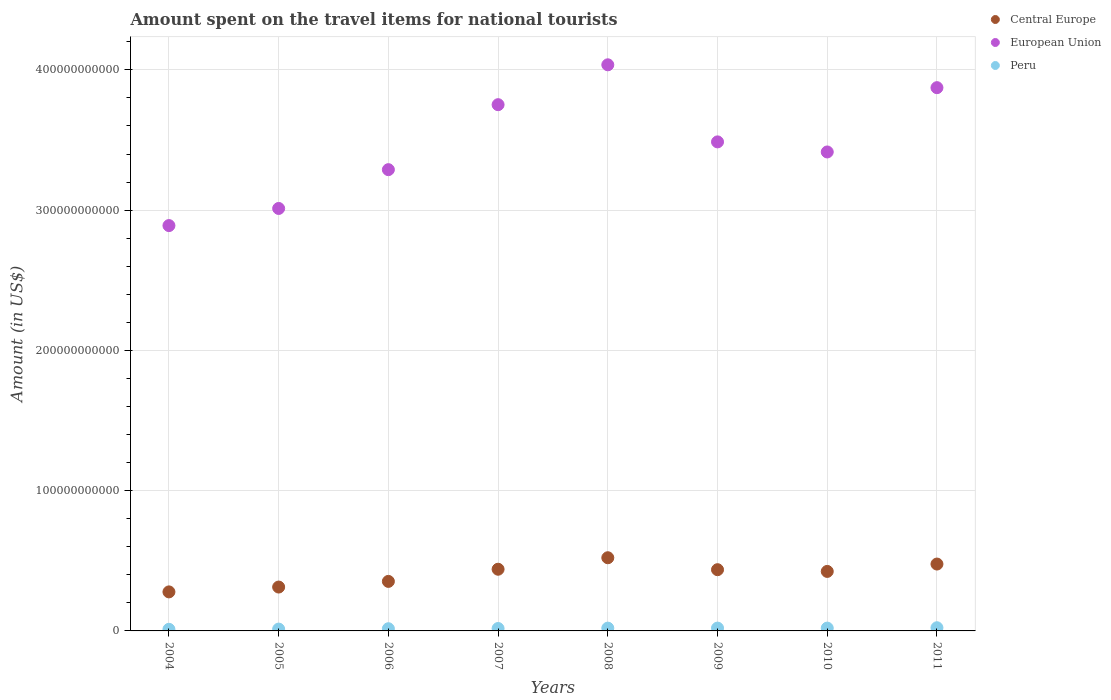How many different coloured dotlines are there?
Your answer should be compact. 3. Is the number of dotlines equal to the number of legend labels?
Provide a short and direct response. Yes. What is the amount spent on the travel items for national tourists in European Union in 2010?
Your answer should be very brief. 3.41e+11. Across all years, what is the maximum amount spent on the travel items for national tourists in Peru?
Your answer should be very brief. 2.26e+09. Across all years, what is the minimum amount spent on the travel items for national tourists in Central Europe?
Offer a very short reply. 2.78e+1. In which year was the amount spent on the travel items for national tourists in European Union maximum?
Your answer should be compact. 2008. What is the total amount spent on the travel items for national tourists in Peru in the graph?
Ensure brevity in your answer.  1.40e+1. What is the difference between the amount spent on the travel items for national tourists in European Union in 2007 and that in 2009?
Your response must be concise. 2.65e+1. What is the difference between the amount spent on the travel items for national tourists in European Union in 2004 and the amount spent on the travel items for national tourists in Peru in 2010?
Keep it short and to the point. 2.87e+11. What is the average amount spent on the travel items for national tourists in European Union per year?
Make the answer very short. 3.47e+11. In the year 2007, what is the difference between the amount spent on the travel items for national tourists in European Union and amount spent on the travel items for national tourists in Peru?
Provide a short and direct response. 3.73e+11. What is the ratio of the amount spent on the travel items for national tourists in Peru in 2005 to that in 2008?
Provide a succinct answer. 0.66. Is the difference between the amount spent on the travel items for national tourists in European Union in 2008 and 2010 greater than the difference between the amount spent on the travel items for national tourists in Peru in 2008 and 2010?
Your answer should be compact. Yes. What is the difference between the highest and the second highest amount spent on the travel items for national tourists in European Union?
Your answer should be compact. 1.63e+1. What is the difference between the highest and the lowest amount spent on the travel items for national tourists in Peru?
Provide a short and direct response. 1.12e+09. Is the sum of the amount spent on the travel items for national tourists in Peru in 2006 and 2009 greater than the maximum amount spent on the travel items for national tourists in European Union across all years?
Your answer should be compact. No. Does the amount spent on the travel items for national tourists in European Union monotonically increase over the years?
Ensure brevity in your answer.  No. Is the amount spent on the travel items for national tourists in Central Europe strictly greater than the amount spent on the travel items for national tourists in Peru over the years?
Your answer should be compact. Yes. How many dotlines are there?
Make the answer very short. 3. What is the difference between two consecutive major ticks on the Y-axis?
Your response must be concise. 1.00e+11. Are the values on the major ticks of Y-axis written in scientific E-notation?
Ensure brevity in your answer.  No. Does the graph contain grids?
Provide a short and direct response. Yes. What is the title of the graph?
Your response must be concise. Amount spent on the travel items for national tourists. What is the label or title of the X-axis?
Provide a short and direct response. Years. What is the Amount (in US$) of Central Europe in 2004?
Give a very brief answer. 2.78e+1. What is the Amount (in US$) in European Union in 2004?
Offer a very short reply. 2.89e+11. What is the Amount (in US$) in Peru in 2004?
Offer a very short reply. 1.14e+09. What is the Amount (in US$) in Central Europe in 2005?
Your response must be concise. 3.13e+1. What is the Amount (in US$) in European Union in 2005?
Ensure brevity in your answer.  3.01e+11. What is the Amount (in US$) of Peru in 2005?
Ensure brevity in your answer.  1.31e+09. What is the Amount (in US$) in Central Europe in 2006?
Make the answer very short. 3.53e+1. What is the Amount (in US$) of European Union in 2006?
Provide a short and direct response. 3.29e+11. What is the Amount (in US$) of Peru in 2006?
Provide a short and direct response. 1.57e+09. What is the Amount (in US$) of Central Europe in 2007?
Make the answer very short. 4.40e+1. What is the Amount (in US$) in European Union in 2007?
Your response must be concise. 3.75e+11. What is the Amount (in US$) in Peru in 2007?
Ensure brevity in your answer.  1.72e+09. What is the Amount (in US$) in Central Europe in 2008?
Provide a succinct answer. 5.22e+1. What is the Amount (in US$) in European Union in 2008?
Your answer should be very brief. 4.04e+11. What is the Amount (in US$) of Peru in 2008?
Offer a very short reply. 1.99e+09. What is the Amount (in US$) of Central Europe in 2009?
Keep it short and to the point. 4.37e+1. What is the Amount (in US$) in European Union in 2009?
Your answer should be very brief. 3.49e+11. What is the Amount (in US$) of Peru in 2009?
Your answer should be compact. 2.01e+09. What is the Amount (in US$) of Central Europe in 2010?
Ensure brevity in your answer.  4.24e+1. What is the Amount (in US$) in European Union in 2010?
Provide a short and direct response. 3.41e+11. What is the Amount (in US$) in Peru in 2010?
Give a very brief answer. 2.01e+09. What is the Amount (in US$) in Central Europe in 2011?
Your answer should be very brief. 4.77e+1. What is the Amount (in US$) of European Union in 2011?
Offer a terse response. 3.87e+11. What is the Amount (in US$) in Peru in 2011?
Make the answer very short. 2.26e+09. Across all years, what is the maximum Amount (in US$) in Central Europe?
Provide a short and direct response. 5.22e+1. Across all years, what is the maximum Amount (in US$) of European Union?
Offer a terse response. 4.04e+11. Across all years, what is the maximum Amount (in US$) in Peru?
Keep it short and to the point. 2.26e+09. Across all years, what is the minimum Amount (in US$) in Central Europe?
Ensure brevity in your answer.  2.78e+1. Across all years, what is the minimum Amount (in US$) in European Union?
Make the answer very short. 2.89e+11. Across all years, what is the minimum Amount (in US$) in Peru?
Ensure brevity in your answer.  1.14e+09. What is the total Amount (in US$) of Central Europe in the graph?
Make the answer very short. 3.24e+11. What is the total Amount (in US$) of European Union in the graph?
Give a very brief answer. 2.78e+12. What is the total Amount (in US$) in Peru in the graph?
Offer a very short reply. 1.40e+1. What is the difference between the Amount (in US$) in Central Europe in 2004 and that in 2005?
Your answer should be compact. -3.45e+09. What is the difference between the Amount (in US$) in European Union in 2004 and that in 2005?
Your answer should be very brief. -1.22e+1. What is the difference between the Amount (in US$) in Peru in 2004 and that in 2005?
Your answer should be very brief. -1.66e+08. What is the difference between the Amount (in US$) of Central Europe in 2004 and that in 2006?
Offer a very short reply. -7.48e+09. What is the difference between the Amount (in US$) of European Union in 2004 and that in 2006?
Offer a terse response. -3.99e+1. What is the difference between the Amount (in US$) in Peru in 2004 and that in 2006?
Offer a terse response. -4.28e+08. What is the difference between the Amount (in US$) of Central Europe in 2004 and that in 2007?
Offer a terse response. -1.62e+1. What is the difference between the Amount (in US$) in European Union in 2004 and that in 2007?
Offer a terse response. -8.62e+1. What is the difference between the Amount (in US$) in Peru in 2004 and that in 2007?
Keep it short and to the point. -5.81e+08. What is the difference between the Amount (in US$) in Central Europe in 2004 and that in 2008?
Give a very brief answer. -2.44e+1. What is the difference between the Amount (in US$) in European Union in 2004 and that in 2008?
Your response must be concise. -1.15e+11. What is the difference between the Amount (in US$) of Peru in 2004 and that in 2008?
Offer a very short reply. -8.49e+08. What is the difference between the Amount (in US$) of Central Europe in 2004 and that in 2009?
Ensure brevity in your answer.  -1.58e+1. What is the difference between the Amount (in US$) of European Union in 2004 and that in 2009?
Keep it short and to the point. -5.97e+1. What is the difference between the Amount (in US$) of Peru in 2004 and that in 2009?
Your response must be concise. -8.72e+08. What is the difference between the Amount (in US$) of Central Europe in 2004 and that in 2010?
Provide a succinct answer. -1.46e+1. What is the difference between the Amount (in US$) in European Union in 2004 and that in 2010?
Your answer should be compact. -5.25e+1. What is the difference between the Amount (in US$) of Peru in 2004 and that in 2010?
Make the answer very short. -8.66e+08. What is the difference between the Amount (in US$) in Central Europe in 2004 and that in 2011?
Give a very brief answer. -1.99e+1. What is the difference between the Amount (in US$) of European Union in 2004 and that in 2011?
Provide a succinct answer. -9.83e+1. What is the difference between the Amount (in US$) in Peru in 2004 and that in 2011?
Offer a terse response. -1.12e+09. What is the difference between the Amount (in US$) of Central Europe in 2005 and that in 2006?
Make the answer very short. -4.03e+09. What is the difference between the Amount (in US$) in European Union in 2005 and that in 2006?
Offer a very short reply. -2.77e+1. What is the difference between the Amount (in US$) of Peru in 2005 and that in 2006?
Give a very brief answer. -2.62e+08. What is the difference between the Amount (in US$) of Central Europe in 2005 and that in 2007?
Provide a short and direct response. -1.27e+1. What is the difference between the Amount (in US$) of European Union in 2005 and that in 2007?
Ensure brevity in your answer.  -7.40e+1. What is the difference between the Amount (in US$) of Peru in 2005 and that in 2007?
Give a very brief answer. -4.15e+08. What is the difference between the Amount (in US$) in Central Europe in 2005 and that in 2008?
Make the answer very short. -2.09e+1. What is the difference between the Amount (in US$) of European Union in 2005 and that in 2008?
Your response must be concise. -1.02e+11. What is the difference between the Amount (in US$) of Peru in 2005 and that in 2008?
Ensure brevity in your answer.  -6.83e+08. What is the difference between the Amount (in US$) in Central Europe in 2005 and that in 2009?
Offer a terse response. -1.24e+1. What is the difference between the Amount (in US$) of European Union in 2005 and that in 2009?
Give a very brief answer. -4.75e+1. What is the difference between the Amount (in US$) in Peru in 2005 and that in 2009?
Ensure brevity in your answer.  -7.06e+08. What is the difference between the Amount (in US$) in Central Europe in 2005 and that in 2010?
Make the answer very short. -1.11e+1. What is the difference between the Amount (in US$) of European Union in 2005 and that in 2010?
Your answer should be very brief. -4.03e+1. What is the difference between the Amount (in US$) of Peru in 2005 and that in 2010?
Your answer should be compact. -7.00e+08. What is the difference between the Amount (in US$) in Central Europe in 2005 and that in 2011?
Offer a terse response. -1.64e+1. What is the difference between the Amount (in US$) of European Union in 2005 and that in 2011?
Your answer should be very brief. -8.61e+1. What is the difference between the Amount (in US$) of Peru in 2005 and that in 2011?
Ensure brevity in your answer.  -9.54e+08. What is the difference between the Amount (in US$) in Central Europe in 2006 and that in 2007?
Make the answer very short. -8.67e+09. What is the difference between the Amount (in US$) in European Union in 2006 and that in 2007?
Offer a very short reply. -4.63e+1. What is the difference between the Amount (in US$) of Peru in 2006 and that in 2007?
Make the answer very short. -1.53e+08. What is the difference between the Amount (in US$) of Central Europe in 2006 and that in 2008?
Provide a succinct answer. -1.69e+1. What is the difference between the Amount (in US$) in European Union in 2006 and that in 2008?
Give a very brief answer. -7.48e+1. What is the difference between the Amount (in US$) of Peru in 2006 and that in 2008?
Provide a succinct answer. -4.21e+08. What is the difference between the Amount (in US$) in Central Europe in 2006 and that in 2009?
Your response must be concise. -8.34e+09. What is the difference between the Amount (in US$) in European Union in 2006 and that in 2009?
Offer a terse response. -1.98e+1. What is the difference between the Amount (in US$) of Peru in 2006 and that in 2009?
Provide a succinct answer. -4.44e+08. What is the difference between the Amount (in US$) in Central Europe in 2006 and that in 2010?
Provide a short and direct response. -7.11e+09. What is the difference between the Amount (in US$) of European Union in 2006 and that in 2010?
Your answer should be compact. -1.26e+1. What is the difference between the Amount (in US$) in Peru in 2006 and that in 2010?
Keep it short and to the point. -4.38e+08. What is the difference between the Amount (in US$) of Central Europe in 2006 and that in 2011?
Make the answer very short. -1.24e+1. What is the difference between the Amount (in US$) in European Union in 2006 and that in 2011?
Make the answer very short. -5.85e+1. What is the difference between the Amount (in US$) of Peru in 2006 and that in 2011?
Provide a short and direct response. -6.92e+08. What is the difference between the Amount (in US$) of Central Europe in 2007 and that in 2008?
Keep it short and to the point. -8.20e+09. What is the difference between the Amount (in US$) of European Union in 2007 and that in 2008?
Make the answer very short. -2.84e+1. What is the difference between the Amount (in US$) in Peru in 2007 and that in 2008?
Offer a very short reply. -2.68e+08. What is the difference between the Amount (in US$) in Central Europe in 2007 and that in 2009?
Your answer should be very brief. 3.28e+08. What is the difference between the Amount (in US$) of European Union in 2007 and that in 2009?
Offer a terse response. 2.65e+1. What is the difference between the Amount (in US$) in Peru in 2007 and that in 2009?
Offer a very short reply. -2.91e+08. What is the difference between the Amount (in US$) of Central Europe in 2007 and that in 2010?
Your answer should be very brief. 1.56e+09. What is the difference between the Amount (in US$) of European Union in 2007 and that in 2010?
Offer a terse response. 3.37e+1. What is the difference between the Amount (in US$) of Peru in 2007 and that in 2010?
Give a very brief answer. -2.85e+08. What is the difference between the Amount (in US$) of Central Europe in 2007 and that in 2011?
Your answer should be very brief. -3.70e+09. What is the difference between the Amount (in US$) of European Union in 2007 and that in 2011?
Make the answer very short. -1.21e+1. What is the difference between the Amount (in US$) in Peru in 2007 and that in 2011?
Your response must be concise. -5.39e+08. What is the difference between the Amount (in US$) in Central Europe in 2008 and that in 2009?
Your answer should be compact. 8.52e+09. What is the difference between the Amount (in US$) of European Union in 2008 and that in 2009?
Offer a very short reply. 5.50e+1. What is the difference between the Amount (in US$) of Peru in 2008 and that in 2009?
Provide a succinct answer. -2.30e+07. What is the difference between the Amount (in US$) of Central Europe in 2008 and that in 2010?
Give a very brief answer. 9.75e+09. What is the difference between the Amount (in US$) in European Union in 2008 and that in 2010?
Keep it short and to the point. 6.21e+1. What is the difference between the Amount (in US$) of Peru in 2008 and that in 2010?
Make the answer very short. -1.70e+07. What is the difference between the Amount (in US$) in Central Europe in 2008 and that in 2011?
Your response must be concise. 4.50e+09. What is the difference between the Amount (in US$) of European Union in 2008 and that in 2011?
Ensure brevity in your answer.  1.63e+1. What is the difference between the Amount (in US$) of Peru in 2008 and that in 2011?
Your answer should be compact. -2.71e+08. What is the difference between the Amount (in US$) in Central Europe in 2009 and that in 2010?
Your answer should be very brief. 1.23e+09. What is the difference between the Amount (in US$) in European Union in 2009 and that in 2010?
Your response must be concise. 7.18e+09. What is the difference between the Amount (in US$) in Peru in 2009 and that in 2010?
Provide a short and direct response. 6.00e+06. What is the difference between the Amount (in US$) in Central Europe in 2009 and that in 2011?
Provide a succinct answer. -4.02e+09. What is the difference between the Amount (in US$) in European Union in 2009 and that in 2011?
Provide a short and direct response. -3.87e+1. What is the difference between the Amount (in US$) of Peru in 2009 and that in 2011?
Give a very brief answer. -2.48e+08. What is the difference between the Amount (in US$) in Central Europe in 2010 and that in 2011?
Give a very brief answer. -5.25e+09. What is the difference between the Amount (in US$) of European Union in 2010 and that in 2011?
Your answer should be compact. -4.58e+1. What is the difference between the Amount (in US$) in Peru in 2010 and that in 2011?
Provide a succinct answer. -2.54e+08. What is the difference between the Amount (in US$) of Central Europe in 2004 and the Amount (in US$) of European Union in 2005?
Ensure brevity in your answer.  -2.73e+11. What is the difference between the Amount (in US$) of Central Europe in 2004 and the Amount (in US$) of Peru in 2005?
Your answer should be very brief. 2.65e+1. What is the difference between the Amount (in US$) of European Union in 2004 and the Amount (in US$) of Peru in 2005?
Provide a succinct answer. 2.88e+11. What is the difference between the Amount (in US$) of Central Europe in 2004 and the Amount (in US$) of European Union in 2006?
Your answer should be compact. -3.01e+11. What is the difference between the Amount (in US$) of Central Europe in 2004 and the Amount (in US$) of Peru in 2006?
Offer a terse response. 2.63e+1. What is the difference between the Amount (in US$) in European Union in 2004 and the Amount (in US$) in Peru in 2006?
Ensure brevity in your answer.  2.87e+11. What is the difference between the Amount (in US$) of Central Europe in 2004 and the Amount (in US$) of European Union in 2007?
Make the answer very short. -3.47e+11. What is the difference between the Amount (in US$) of Central Europe in 2004 and the Amount (in US$) of Peru in 2007?
Offer a terse response. 2.61e+1. What is the difference between the Amount (in US$) of European Union in 2004 and the Amount (in US$) of Peru in 2007?
Offer a terse response. 2.87e+11. What is the difference between the Amount (in US$) of Central Europe in 2004 and the Amount (in US$) of European Union in 2008?
Make the answer very short. -3.76e+11. What is the difference between the Amount (in US$) of Central Europe in 2004 and the Amount (in US$) of Peru in 2008?
Make the answer very short. 2.58e+1. What is the difference between the Amount (in US$) of European Union in 2004 and the Amount (in US$) of Peru in 2008?
Provide a succinct answer. 2.87e+11. What is the difference between the Amount (in US$) of Central Europe in 2004 and the Amount (in US$) of European Union in 2009?
Your answer should be compact. -3.21e+11. What is the difference between the Amount (in US$) in Central Europe in 2004 and the Amount (in US$) in Peru in 2009?
Your response must be concise. 2.58e+1. What is the difference between the Amount (in US$) in European Union in 2004 and the Amount (in US$) in Peru in 2009?
Your answer should be compact. 2.87e+11. What is the difference between the Amount (in US$) in Central Europe in 2004 and the Amount (in US$) in European Union in 2010?
Your response must be concise. -3.14e+11. What is the difference between the Amount (in US$) in Central Europe in 2004 and the Amount (in US$) in Peru in 2010?
Provide a short and direct response. 2.58e+1. What is the difference between the Amount (in US$) of European Union in 2004 and the Amount (in US$) of Peru in 2010?
Keep it short and to the point. 2.87e+11. What is the difference between the Amount (in US$) of Central Europe in 2004 and the Amount (in US$) of European Union in 2011?
Ensure brevity in your answer.  -3.59e+11. What is the difference between the Amount (in US$) in Central Europe in 2004 and the Amount (in US$) in Peru in 2011?
Your response must be concise. 2.56e+1. What is the difference between the Amount (in US$) of European Union in 2004 and the Amount (in US$) of Peru in 2011?
Ensure brevity in your answer.  2.87e+11. What is the difference between the Amount (in US$) of Central Europe in 2005 and the Amount (in US$) of European Union in 2006?
Offer a very short reply. -2.98e+11. What is the difference between the Amount (in US$) of Central Europe in 2005 and the Amount (in US$) of Peru in 2006?
Provide a succinct answer. 2.97e+1. What is the difference between the Amount (in US$) of European Union in 2005 and the Amount (in US$) of Peru in 2006?
Offer a terse response. 3.00e+11. What is the difference between the Amount (in US$) of Central Europe in 2005 and the Amount (in US$) of European Union in 2007?
Your answer should be very brief. -3.44e+11. What is the difference between the Amount (in US$) of Central Europe in 2005 and the Amount (in US$) of Peru in 2007?
Your answer should be very brief. 2.96e+1. What is the difference between the Amount (in US$) of European Union in 2005 and the Amount (in US$) of Peru in 2007?
Make the answer very short. 2.99e+11. What is the difference between the Amount (in US$) of Central Europe in 2005 and the Amount (in US$) of European Union in 2008?
Provide a short and direct response. -3.72e+11. What is the difference between the Amount (in US$) of Central Europe in 2005 and the Amount (in US$) of Peru in 2008?
Make the answer very short. 2.93e+1. What is the difference between the Amount (in US$) of European Union in 2005 and the Amount (in US$) of Peru in 2008?
Offer a terse response. 2.99e+11. What is the difference between the Amount (in US$) of Central Europe in 2005 and the Amount (in US$) of European Union in 2009?
Your answer should be very brief. -3.17e+11. What is the difference between the Amount (in US$) of Central Europe in 2005 and the Amount (in US$) of Peru in 2009?
Your response must be concise. 2.93e+1. What is the difference between the Amount (in US$) of European Union in 2005 and the Amount (in US$) of Peru in 2009?
Keep it short and to the point. 2.99e+11. What is the difference between the Amount (in US$) in Central Europe in 2005 and the Amount (in US$) in European Union in 2010?
Offer a very short reply. -3.10e+11. What is the difference between the Amount (in US$) of Central Europe in 2005 and the Amount (in US$) of Peru in 2010?
Offer a terse response. 2.93e+1. What is the difference between the Amount (in US$) in European Union in 2005 and the Amount (in US$) in Peru in 2010?
Make the answer very short. 2.99e+11. What is the difference between the Amount (in US$) in Central Europe in 2005 and the Amount (in US$) in European Union in 2011?
Your answer should be very brief. -3.56e+11. What is the difference between the Amount (in US$) in Central Europe in 2005 and the Amount (in US$) in Peru in 2011?
Offer a terse response. 2.90e+1. What is the difference between the Amount (in US$) of European Union in 2005 and the Amount (in US$) of Peru in 2011?
Your answer should be very brief. 2.99e+11. What is the difference between the Amount (in US$) of Central Europe in 2006 and the Amount (in US$) of European Union in 2007?
Ensure brevity in your answer.  -3.40e+11. What is the difference between the Amount (in US$) of Central Europe in 2006 and the Amount (in US$) of Peru in 2007?
Your answer should be very brief. 3.36e+1. What is the difference between the Amount (in US$) in European Union in 2006 and the Amount (in US$) in Peru in 2007?
Provide a short and direct response. 3.27e+11. What is the difference between the Amount (in US$) in Central Europe in 2006 and the Amount (in US$) in European Union in 2008?
Give a very brief answer. -3.68e+11. What is the difference between the Amount (in US$) in Central Europe in 2006 and the Amount (in US$) in Peru in 2008?
Your answer should be very brief. 3.33e+1. What is the difference between the Amount (in US$) in European Union in 2006 and the Amount (in US$) in Peru in 2008?
Ensure brevity in your answer.  3.27e+11. What is the difference between the Amount (in US$) of Central Europe in 2006 and the Amount (in US$) of European Union in 2009?
Your answer should be compact. -3.13e+11. What is the difference between the Amount (in US$) of Central Europe in 2006 and the Amount (in US$) of Peru in 2009?
Offer a terse response. 3.33e+1. What is the difference between the Amount (in US$) in European Union in 2006 and the Amount (in US$) in Peru in 2009?
Give a very brief answer. 3.27e+11. What is the difference between the Amount (in US$) of Central Europe in 2006 and the Amount (in US$) of European Union in 2010?
Provide a short and direct response. -3.06e+11. What is the difference between the Amount (in US$) in Central Europe in 2006 and the Amount (in US$) in Peru in 2010?
Provide a short and direct response. 3.33e+1. What is the difference between the Amount (in US$) in European Union in 2006 and the Amount (in US$) in Peru in 2010?
Make the answer very short. 3.27e+11. What is the difference between the Amount (in US$) in Central Europe in 2006 and the Amount (in US$) in European Union in 2011?
Ensure brevity in your answer.  -3.52e+11. What is the difference between the Amount (in US$) of Central Europe in 2006 and the Amount (in US$) of Peru in 2011?
Make the answer very short. 3.30e+1. What is the difference between the Amount (in US$) in European Union in 2006 and the Amount (in US$) in Peru in 2011?
Offer a terse response. 3.27e+11. What is the difference between the Amount (in US$) in Central Europe in 2007 and the Amount (in US$) in European Union in 2008?
Make the answer very short. -3.60e+11. What is the difference between the Amount (in US$) in Central Europe in 2007 and the Amount (in US$) in Peru in 2008?
Give a very brief answer. 4.20e+1. What is the difference between the Amount (in US$) of European Union in 2007 and the Amount (in US$) of Peru in 2008?
Offer a terse response. 3.73e+11. What is the difference between the Amount (in US$) of Central Europe in 2007 and the Amount (in US$) of European Union in 2009?
Provide a succinct answer. -3.05e+11. What is the difference between the Amount (in US$) in Central Europe in 2007 and the Amount (in US$) in Peru in 2009?
Offer a very short reply. 4.20e+1. What is the difference between the Amount (in US$) in European Union in 2007 and the Amount (in US$) in Peru in 2009?
Make the answer very short. 3.73e+11. What is the difference between the Amount (in US$) of Central Europe in 2007 and the Amount (in US$) of European Union in 2010?
Your response must be concise. -2.97e+11. What is the difference between the Amount (in US$) of Central Europe in 2007 and the Amount (in US$) of Peru in 2010?
Offer a very short reply. 4.20e+1. What is the difference between the Amount (in US$) of European Union in 2007 and the Amount (in US$) of Peru in 2010?
Offer a very short reply. 3.73e+11. What is the difference between the Amount (in US$) in Central Europe in 2007 and the Amount (in US$) in European Union in 2011?
Offer a terse response. -3.43e+11. What is the difference between the Amount (in US$) in Central Europe in 2007 and the Amount (in US$) in Peru in 2011?
Offer a terse response. 4.17e+1. What is the difference between the Amount (in US$) of European Union in 2007 and the Amount (in US$) of Peru in 2011?
Provide a short and direct response. 3.73e+11. What is the difference between the Amount (in US$) of Central Europe in 2008 and the Amount (in US$) of European Union in 2009?
Your answer should be compact. -2.96e+11. What is the difference between the Amount (in US$) of Central Europe in 2008 and the Amount (in US$) of Peru in 2009?
Keep it short and to the point. 5.02e+1. What is the difference between the Amount (in US$) in European Union in 2008 and the Amount (in US$) in Peru in 2009?
Give a very brief answer. 4.02e+11. What is the difference between the Amount (in US$) in Central Europe in 2008 and the Amount (in US$) in European Union in 2010?
Make the answer very short. -2.89e+11. What is the difference between the Amount (in US$) of Central Europe in 2008 and the Amount (in US$) of Peru in 2010?
Your answer should be very brief. 5.02e+1. What is the difference between the Amount (in US$) in European Union in 2008 and the Amount (in US$) in Peru in 2010?
Provide a succinct answer. 4.02e+11. What is the difference between the Amount (in US$) of Central Europe in 2008 and the Amount (in US$) of European Union in 2011?
Your answer should be very brief. -3.35e+11. What is the difference between the Amount (in US$) of Central Europe in 2008 and the Amount (in US$) of Peru in 2011?
Make the answer very short. 4.99e+1. What is the difference between the Amount (in US$) in European Union in 2008 and the Amount (in US$) in Peru in 2011?
Provide a succinct answer. 4.01e+11. What is the difference between the Amount (in US$) in Central Europe in 2009 and the Amount (in US$) in European Union in 2010?
Your response must be concise. -2.98e+11. What is the difference between the Amount (in US$) in Central Europe in 2009 and the Amount (in US$) in Peru in 2010?
Your answer should be compact. 4.16e+1. What is the difference between the Amount (in US$) of European Union in 2009 and the Amount (in US$) of Peru in 2010?
Your response must be concise. 3.47e+11. What is the difference between the Amount (in US$) in Central Europe in 2009 and the Amount (in US$) in European Union in 2011?
Provide a succinct answer. -3.44e+11. What is the difference between the Amount (in US$) of Central Europe in 2009 and the Amount (in US$) of Peru in 2011?
Give a very brief answer. 4.14e+1. What is the difference between the Amount (in US$) in European Union in 2009 and the Amount (in US$) in Peru in 2011?
Your response must be concise. 3.46e+11. What is the difference between the Amount (in US$) of Central Europe in 2010 and the Amount (in US$) of European Union in 2011?
Give a very brief answer. -3.45e+11. What is the difference between the Amount (in US$) in Central Europe in 2010 and the Amount (in US$) in Peru in 2011?
Keep it short and to the point. 4.02e+1. What is the difference between the Amount (in US$) of European Union in 2010 and the Amount (in US$) of Peru in 2011?
Make the answer very short. 3.39e+11. What is the average Amount (in US$) of Central Europe per year?
Provide a short and direct response. 4.05e+1. What is the average Amount (in US$) in European Union per year?
Provide a succinct answer. 3.47e+11. What is the average Amount (in US$) of Peru per year?
Your answer should be very brief. 1.75e+09. In the year 2004, what is the difference between the Amount (in US$) of Central Europe and Amount (in US$) of European Union?
Make the answer very short. -2.61e+11. In the year 2004, what is the difference between the Amount (in US$) of Central Europe and Amount (in US$) of Peru?
Your response must be concise. 2.67e+1. In the year 2004, what is the difference between the Amount (in US$) of European Union and Amount (in US$) of Peru?
Offer a terse response. 2.88e+11. In the year 2005, what is the difference between the Amount (in US$) in Central Europe and Amount (in US$) in European Union?
Your answer should be very brief. -2.70e+11. In the year 2005, what is the difference between the Amount (in US$) of Central Europe and Amount (in US$) of Peru?
Your answer should be very brief. 3.00e+1. In the year 2005, what is the difference between the Amount (in US$) in European Union and Amount (in US$) in Peru?
Offer a terse response. 3.00e+11. In the year 2006, what is the difference between the Amount (in US$) in Central Europe and Amount (in US$) in European Union?
Give a very brief answer. -2.94e+11. In the year 2006, what is the difference between the Amount (in US$) in Central Europe and Amount (in US$) in Peru?
Ensure brevity in your answer.  3.37e+1. In the year 2006, what is the difference between the Amount (in US$) in European Union and Amount (in US$) in Peru?
Your response must be concise. 3.27e+11. In the year 2007, what is the difference between the Amount (in US$) in Central Europe and Amount (in US$) in European Union?
Provide a succinct answer. -3.31e+11. In the year 2007, what is the difference between the Amount (in US$) of Central Europe and Amount (in US$) of Peru?
Your response must be concise. 4.23e+1. In the year 2007, what is the difference between the Amount (in US$) in European Union and Amount (in US$) in Peru?
Your response must be concise. 3.73e+11. In the year 2008, what is the difference between the Amount (in US$) in Central Europe and Amount (in US$) in European Union?
Make the answer very short. -3.51e+11. In the year 2008, what is the difference between the Amount (in US$) of Central Europe and Amount (in US$) of Peru?
Provide a succinct answer. 5.02e+1. In the year 2008, what is the difference between the Amount (in US$) in European Union and Amount (in US$) in Peru?
Provide a succinct answer. 4.02e+11. In the year 2009, what is the difference between the Amount (in US$) of Central Europe and Amount (in US$) of European Union?
Keep it short and to the point. -3.05e+11. In the year 2009, what is the difference between the Amount (in US$) in Central Europe and Amount (in US$) in Peru?
Provide a short and direct response. 4.16e+1. In the year 2009, what is the difference between the Amount (in US$) in European Union and Amount (in US$) in Peru?
Make the answer very short. 3.47e+11. In the year 2010, what is the difference between the Amount (in US$) in Central Europe and Amount (in US$) in European Union?
Make the answer very short. -2.99e+11. In the year 2010, what is the difference between the Amount (in US$) of Central Europe and Amount (in US$) of Peru?
Your response must be concise. 4.04e+1. In the year 2010, what is the difference between the Amount (in US$) in European Union and Amount (in US$) in Peru?
Provide a short and direct response. 3.39e+11. In the year 2011, what is the difference between the Amount (in US$) of Central Europe and Amount (in US$) of European Union?
Ensure brevity in your answer.  -3.40e+11. In the year 2011, what is the difference between the Amount (in US$) of Central Europe and Amount (in US$) of Peru?
Give a very brief answer. 4.54e+1. In the year 2011, what is the difference between the Amount (in US$) in European Union and Amount (in US$) in Peru?
Offer a very short reply. 3.85e+11. What is the ratio of the Amount (in US$) in Central Europe in 2004 to that in 2005?
Make the answer very short. 0.89. What is the ratio of the Amount (in US$) of European Union in 2004 to that in 2005?
Keep it short and to the point. 0.96. What is the ratio of the Amount (in US$) of Peru in 2004 to that in 2005?
Keep it short and to the point. 0.87. What is the ratio of the Amount (in US$) of Central Europe in 2004 to that in 2006?
Your answer should be compact. 0.79. What is the ratio of the Amount (in US$) of European Union in 2004 to that in 2006?
Give a very brief answer. 0.88. What is the ratio of the Amount (in US$) in Peru in 2004 to that in 2006?
Offer a very short reply. 0.73. What is the ratio of the Amount (in US$) of Central Europe in 2004 to that in 2007?
Make the answer very short. 0.63. What is the ratio of the Amount (in US$) in European Union in 2004 to that in 2007?
Keep it short and to the point. 0.77. What is the ratio of the Amount (in US$) of Peru in 2004 to that in 2007?
Provide a short and direct response. 0.66. What is the ratio of the Amount (in US$) in Central Europe in 2004 to that in 2008?
Make the answer very short. 0.53. What is the ratio of the Amount (in US$) of European Union in 2004 to that in 2008?
Give a very brief answer. 0.72. What is the ratio of the Amount (in US$) of Peru in 2004 to that in 2008?
Ensure brevity in your answer.  0.57. What is the ratio of the Amount (in US$) of Central Europe in 2004 to that in 2009?
Your response must be concise. 0.64. What is the ratio of the Amount (in US$) of European Union in 2004 to that in 2009?
Your answer should be very brief. 0.83. What is the ratio of the Amount (in US$) in Peru in 2004 to that in 2009?
Offer a very short reply. 0.57. What is the ratio of the Amount (in US$) in Central Europe in 2004 to that in 2010?
Give a very brief answer. 0.66. What is the ratio of the Amount (in US$) of European Union in 2004 to that in 2010?
Your answer should be compact. 0.85. What is the ratio of the Amount (in US$) of Peru in 2004 to that in 2010?
Offer a terse response. 0.57. What is the ratio of the Amount (in US$) in Central Europe in 2004 to that in 2011?
Provide a succinct answer. 0.58. What is the ratio of the Amount (in US$) of European Union in 2004 to that in 2011?
Keep it short and to the point. 0.75. What is the ratio of the Amount (in US$) of Peru in 2004 to that in 2011?
Make the answer very short. 0.5. What is the ratio of the Amount (in US$) of Central Europe in 2005 to that in 2006?
Your answer should be very brief. 0.89. What is the ratio of the Amount (in US$) of European Union in 2005 to that in 2006?
Your response must be concise. 0.92. What is the ratio of the Amount (in US$) of Peru in 2005 to that in 2006?
Give a very brief answer. 0.83. What is the ratio of the Amount (in US$) of Central Europe in 2005 to that in 2007?
Your response must be concise. 0.71. What is the ratio of the Amount (in US$) in European Union in 2005 to that in 2007?
Provide a short and direct response. 0.8. What is the ratio of the Amount (in US$) in Peru in 2005 to that in 2007?
Provide a succinct answer. 0.76. What is the ratio of the Amount (in US$) in Central Europe in 2005 to that in 2008?
Your response must be concise. 0.6. What is the ratio of the Amount (in US$) in European Union in 2005 to that in 2008?
Your answer should be compact. 0.75. What is the ratio of the Amount (in US$) of Peru in 2005 to that in 2008?
Keep it short and to the point. 0.66. What is the ratio of the Amount (in US$) in Central Europe in 2005 to that in 2009?
Provide a short and direct response. 0.72. What is the ratio of the Amount (in US$) of European Union in 2005 to that in 2009?
Keep it short and to the point. 0.86. What is the ratio of the Amount (in US$) of Peru in 2005 to that in 2009?
Your response must be concise. 0.65. What is the ratio of the Amount (in US$) in Central Europe in 2005 to that in 2010?
Offer a terse response. 0.74. What is the ratio of the Amount (in US$) of European Union in 2005 to that in 2010?
Ensure brevity in your answer.  0.88. What is the ratio of the Amount (in US$) of Peru in 2005 to that in 2010?
Keep it short and to the point. 0.65. What is the ratio of the Amount (in US$) in Central Europe in 2005 to that in 2011?
Provide a succinct answer. 0.66. What is the ratio of the Amount (in US$) in European Union in 2005 to that in 2011?
Provide a succinct answer. 0.78. What is the ratio of the Amount (in US$) of Peru in 2005 to that in 2011?
Keep it short and to the point. 0.58. What is the ratio of the Amount (in US$) in Central Europe in 2006 to that in 2007?
Ensure brevity in your answer.  0.8. What is the ratio of the Amount (in US$) in European Union in 2006 to that in 2007?
Your answer should be very brief. 0.88. What is the ratio of the Amount (in US$) of Peru in 2006 to that in 2007?
Ensure brevity in your answer.  0.91. What is the ratio of the Amount (in US$) in Central Europe in 2006 to that in 2008?
Ensure brevity in your answer.  0.68. What is the ratio of the Amount (in US$) of European Union in 2006 to that in 2008?
Offer a very short reply. 0.81. What is the ratio of the Amount (in US$) in Peru in 2006 to that in 2008?
Give a very brief answer. 0.79. What is the ratio of the Amount (in US$) of Central Europe in 2006 to that in 2009?
Provide a succinct answer. 0.81. What is the ratio of the Amount (in US$) of European Union in 2006 to that in 2009?
Your answer should be very brief. 0.94. What is the ratio of the Amount (in US$) in Peru in 2006 to that in 2009?
Provide a short and direct response. 0.78. What is the ratio of the Amount (in US$) of Central Europe in 2006 to that in 2010?
Give a very brief answer. 0.83. What is the ratio of the Amount (in US$) in European Union in 2006 to that in 2010?
Make the answer very short. 0.96. What is the ratio of the Amount (in US$) in Peru in 2006 to that in 2010?
Provide a succinct answer. 0.78. What is the ratio of the Amount (in US$) in Central Europe in 2006 to that in 2011?
Offer a very short reply. 0.74. What is the ratio of the Amount (in US$) of European Union in 2006 to that in 2011?
Offer a very short reply. 0.85. What is the ratio of the Amount (in US$) of Peru in 2006 to that in 2011?
Give a very brief answer. 0.69. What is the ratio of the Amount (in US$) in Central Europe in 2007 to that in 2008?
Give a very brief answer. 0.84. What is the ratio of the Amount (in US$) in European Union in 2007 to that in 2008?
Provide a short and direct response. 0.93. What is the ratio of the Amount (in US$) in Peru in 2007 to that in 2008?
Make the answer very short. 0.87. What is the ratio of the Amount (in US$) in Central Europe in 2007 to that in 2009?
Provide a short and direct response. 1.01. What is the ratio of the Amount (in US$) in European Union in 2007 to that in 2009?
Your response must be concise. 1.08. What is the ratio of the Amount (in US$) in Peru in 2007 to that in 2009?
Offer a very short reply. 0.86. What is the ratio of the Amount (in US$) in Central Europe in 2007 to that in 2010?
Your answer should be very brief. 1.04. What is the ratio of the Amount (in US$) of European Union in 2007 to that in 2010?
Give a very brief answer. 1.1. What is the ratio of the Amount (in US$) of Peru in 2007 to that in 2010?
Your answer should be compact. 0.86. What is the ratio of the Amount (in US$) in Central Europe in 2007 to that in 2011?
Provide a succinct answer. 0.92. What is the ratio of the Amount (in US$) of European Union in 2007 to that in 2011?
Offer a very short reply. 0.97. What is the ratio of the Amount (in US$) of Peru in 2007 to that in 2011?
Your response must be concise. 0.76. What is the ratio of the Amount (in US$) in Central Europe in 2008 to that in 2009?
Offer a very short reply. 1.2. What is the ratio of the Amount (in US$) in European Union in 2008 to that in 2009?
Provide a succinct answer. 1.16. What is the ratio of the Amount (in US$) of Peru in 2008 to that in 2009?
Keep it short and to the point. 0.99. What is the ratio of the Amount (in US$) in Central Europe in 2008 to that in 2010?
Keep it short and to the point. 1.23. What is the ratio of the Amount (in US$) of European Union in 2008 to that in 2010?
Make the answer very short. 1.18. What is the ratio of the Amount (in US$) in Peru in 2008 to that in 2010?
Your answer should be compact. 0.99. What is the ratio of the Amount (in US$) in Central Europe in 2008 to that in 2011?
Provide a succinct answer. 1.09. What is the ratio of the Amount (in US$) in European Union in 2008 to that in 2011?
Offer a very short reply. 1.04. What is the ratio of the Amount (in US$) of Peru in 2008 to that in 2011?
Give a very brief answer. 0.88. What is the ratio of the Amount (in US$) in Central Europe in 2009 to that in 2010?
Provide a succinct answer. 1.03. What is the ratio of the Amount (in US$) in European Union in 2009 to that in 2010?
Keep it short and to the point. 1.02. What is the ratio of the Amount (in US$) in Central Europe in 2009 to that in 2011?
Make the answer very short. 0.92. What is the ratio of the Amount (in US$) in European Union in 2009 to that in 2011?
Keep it short and to the point. 0.9. What is the ratio of the Amount (in US$) in Peru in 2009 to that in 2011?
Offer a very short reply. 0.89. What is the ratio of the Amount (in US$) in Central Europe in 2010 to that in 2011?
Provide a short and direct response. 0.89. What is the ratio of the Amount (in US$) in European Union in 2010 to that in 2011?
Make the answer very short. 0.88. What is the ratio of the Amount (in US$) of Peru in 2010 to that in 2011?
Your answer should be compact. 0.89. What is the difference between the highest and the second highest Amount (in US$) of Central Europe?
Provide a short and direct response. 4.50e+09. What is the difference between the highest and the second highest Amount (in US$) in European Union?
Your answer should be very brief. 1.63e+1. What is the difference between the highest and the second highest Amount (in US$) of Peru?
Your response must be concise. 2.48e+08. What is the difference between the highest and the lowest Amount (in US$) of Central Europe?
Give a very brief answer. 2.44e+1. What is the difference between the highest and the lowest Amount (in US$) of European Union?
Provide a succinct answer. 1.15e+11. What is the difference between the highest and the lowest Amount (in US$) in Peru?
Provide a succinct answer. 1.12e+09. 